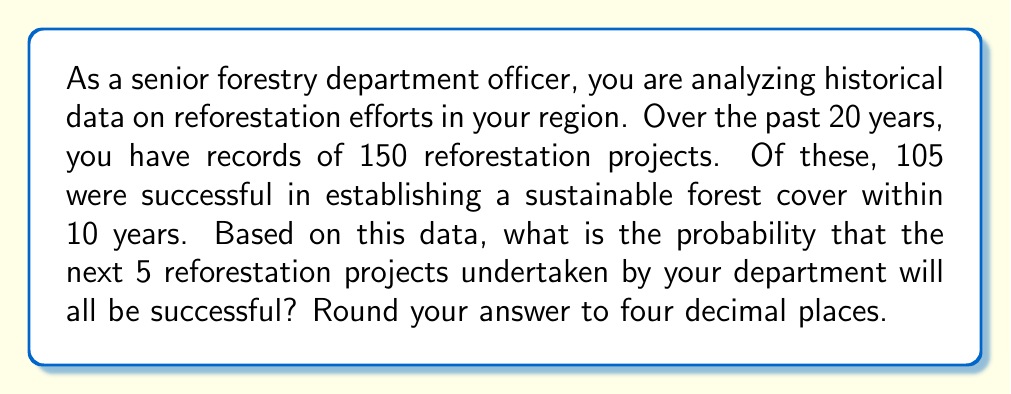Can you answer this question? To solve this problem, we need to follow these steps:

1. Calculate the probability of a single reforestation project being successful.
2. Use this probability to determine the likelihood of all 5 projects being successful.

Step 1: Calculating the probability of a single successful project

The probability of success for a single project is:

$$ P(\text{success}) = \frac{\text{Number of successful projects}}{\text{Total number of projects}} = \frac{105}{150} = 0.7 $$

Step 2: Calculating the probability of all 5 projects being successful

Since we want all 5 projects to be successful, and assuming that the success of each project is independent of the others, we need to multiply the probability of success for each individual project. This is an application of the multiplication rule of probability.

$$ P(\text{all 5 successful}) = P(\text{success})^5 = 0.7^5 $$

Now, let's calculate this:

$$ 0.7^5 = 0.16807 $$

Rounding to four decimal places:

$$ 0.16807 \approx 0.1681 $$

Therefore, the probability that all 5 reforestation projects will be successful is approximately 0.1681 or 16.81%.
Answer: 0.1681 